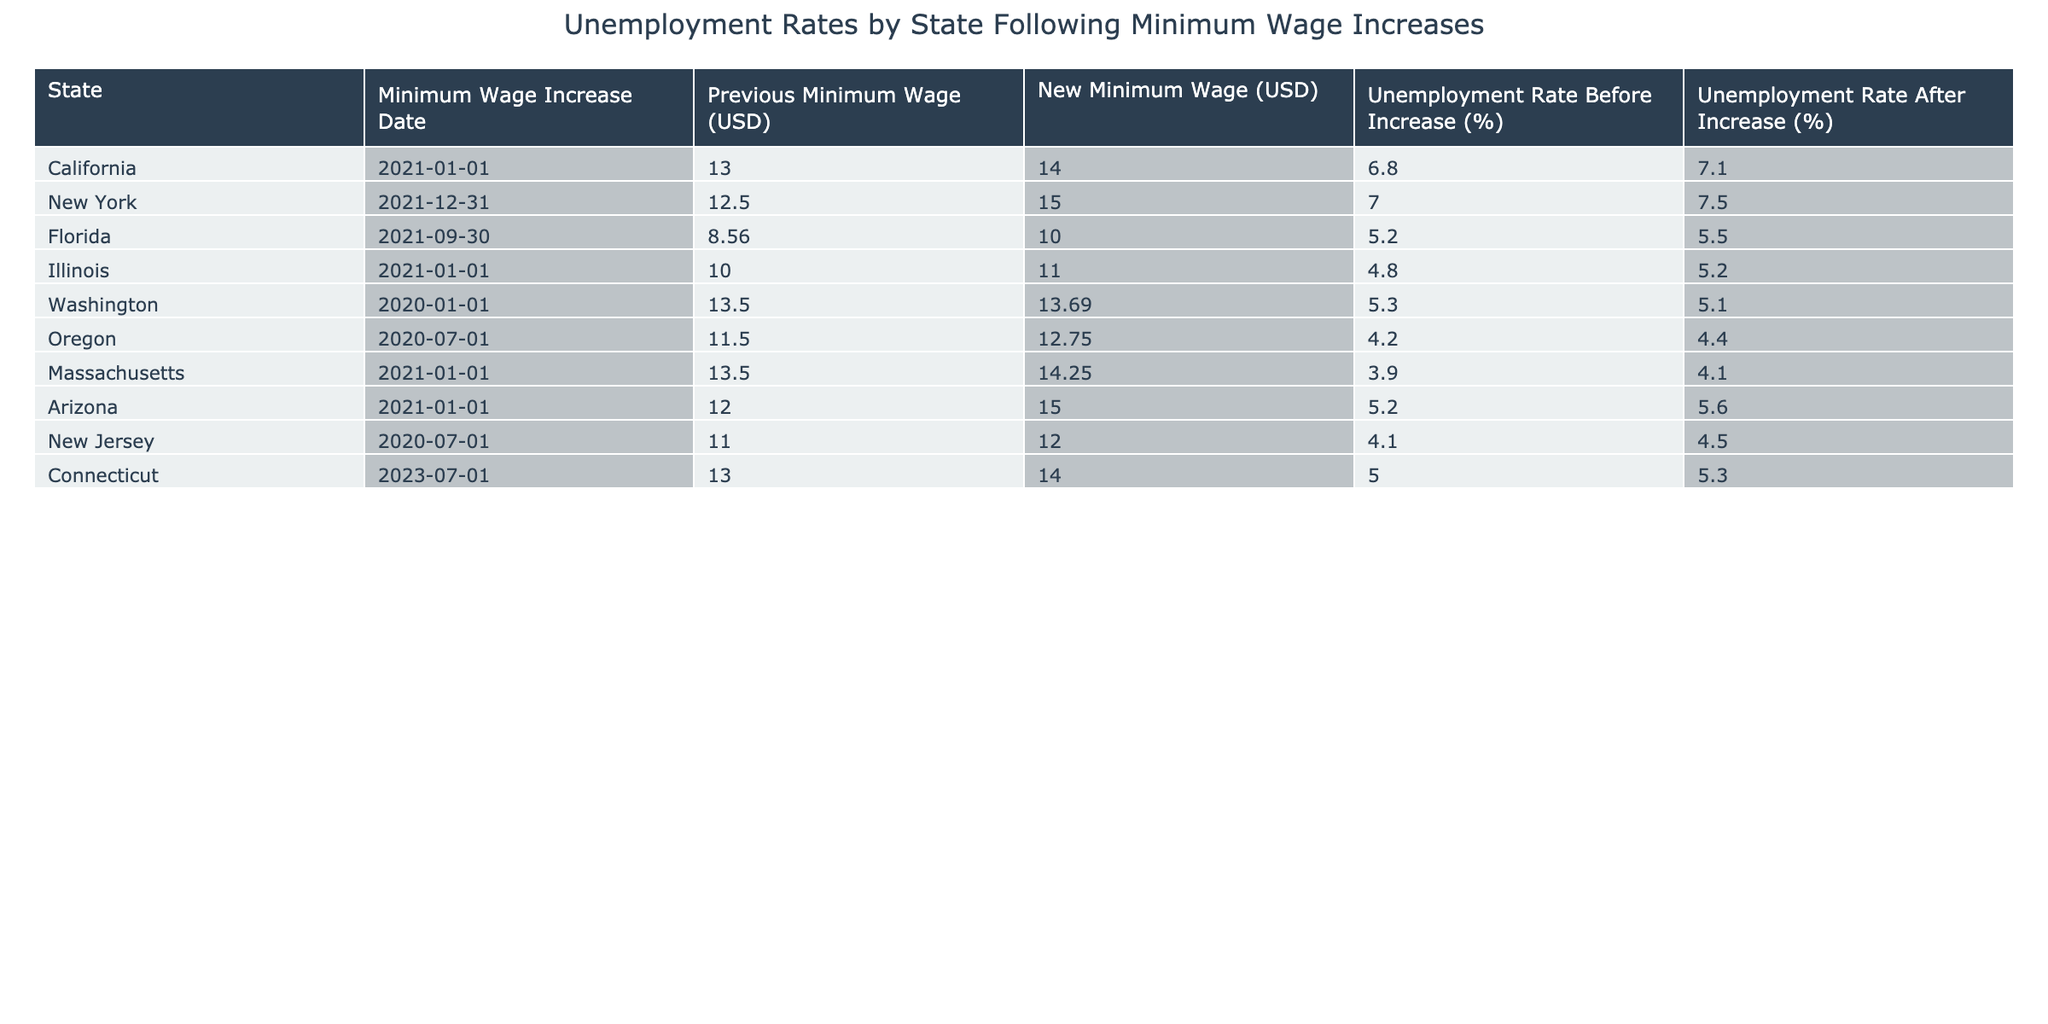What is the previous minimum wage in New York before the increase? The table lists the states, their previous minimum wages before the increase, and the new minimum wages. For New York, the previous minimum wage is stated as 12.50 USD.
Answer: 12.50 USD What is the unemployment rate in California after the minimum wage increase? In the table, California's unemployment rate before the increase is given as 6.8%, and after the increase, it is listed as 7.1%.
Answer: 7.1% What state had the highest unemployment rate before the minimum wage increase? The table shows the unemployment rates before the increase for each state. By comparing these rates, we can see that New York had the highest rate at 7.0%.
Answer: New York How many states experienced an increase in unemployment rate after the minimum wage increase? The table provides unemployment rates before and after for each state. By examining the rates, we find that California, New York, Illinois, Arizona, and Connecticut all had higher rates after the increase. In total, this gives us 5 states.
Answer: 5 states What is the difference in unemployment rates before and after the increase in Massachusetts? The unemployment rate before the increase in Massachusetts is 3.9%, and after the increase, it is 4.1%. To find the difference, we calculate 4.1% - 3.9% = 0.2%.
Answer: 0.2% Which state had the largest increase in the unemployment rate after the minimum wage increase? To find this, we calculate the differences for each state: California (7.1% - 6.8% = 0.3%), New York (7.5% - 7.0% = 0.5%), Florida (5.5% - 5.2% = 0.3%), Illinois (5.2% - 4.8% = 0.4%), etc. The largest increase is in New York with an increase of 0.5%.
Answer: New York Is it true that all states have a minimum wage above 10 USD after their increases? By examining the table, we see that Florida's new minimum wage is 10.00 USD, and all other states have new minimum wages above that amount. Therefore, the statement is true.
Answer: Yes What is the average unemployment rate after the minimum wage increases across all states? We sum the unemployment rates after the increase: 7.1 + 7.5 + 5.5 + 5.2 + 5.1 + 4.4 + 4.1 + 5.6 + 5.3 = 45.4%. Then, we divide by the total number of states (9). The average is 45.4% / 9 = 5.01%.
Answer: 5.01% 